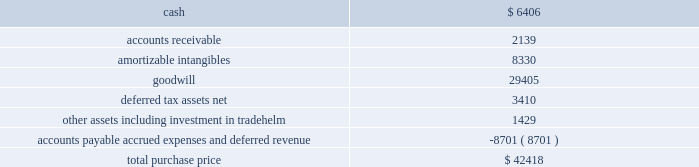Table of contents marketaxess holdings inc .
Notes to consolidated financial statements 2014 ( continued ) of this standard had no material effect on the company 2019s consolidated statements of financial condition and consolidated statements of operations .
Reclassifications certain reclassifications have been made to the prior years 2019 financial statements in order to conform to the current year presentation .
Such reclassifications had no effect on previously reported net income .
On march 5 , 2008 , the company acquired all of the outstanding capital stock of greenline financial technologies , inc .
( 201cgreenline 201d ) , an illinois-based provider of integration , testing and management solutions for fix-related products and services designed to optimize electronic trading of fixed-income , equity and other exchange-based products , and approximately ten percent of the outstanding capital stock of tradehelm , inc. , a delaware corporation that was spun-out from greenline immediately prior to the acquisition .
The acquisition of greenline broadens the range of technology services that the company offers to institutional financial markets , provides an expansion of the company 2019s client base , including global exchanges and hedge funds , and further diversifies the company 2019s revenues beyond the core electronic credit trading products .
The results of operations of greenline are included in the consolidated financial statements from the date of the acquisition .
The aggregate consideration for the greenline acquisition was $ 41.1 million , comprised of $ 34.7 million in cash , 725923 shares of common stock valued at $ 5.8 million and $ 0.6 million of acquisition-related costs .
In addition , the sellers were eligible to receive up to an aggregate of $ 3.0 million in cash , subject to greenline attaining certain earn- out targets in 2008 and 2009 .
A total of $ 1.4 million was paid to the sellers in 2009 based on the 2008 earn-out target , bringing the aggregate consideration to $ 42.4 million .
The 2009 earn-out target was not met .
A total of $ 2.0 million of the purchase price , which had been deposited into escrow accounts to satisfy potential indemnity claims , was distributed to the sellers in march 2009 .
The shares of common stock issued to each selling shareholder of greenline were released in two equal installments on december 20 , 2008 and december 20 , 2009 , respectively .
The value ascribed to the shares was discounted from the market value to reflect the non-marketability of such shares during the restriction period .
The purchase price allocation is as follows ( in thousands ) : the amortizable intangibles include $ 3.2 million of acquired technology , $ 3.3 million of customer relationships , $ 1.3 million of non-competition agreements and $ 0.5 million of tradenames .
Useful lives of ten years and five years have been assigned to the customer relationships intangible and all other amortizable intangibles , respectively .
The identifiable intangible assets and goodwill are not deductible for tax purposes .
The following unaudited pro forma consolidated financial information reflects the results of operations of the company for the years ended december 31 , 2008 and 2007 , as if the acquisition of greenline had occurred as of the beginning of the period presented , after giving effect to certain purchase accounting adjustments .
These pro forma results are not necessarily indicative of what the company 2019s operating results would have been had the acquisition actually taken place as of the beginning of the earliest period presented .
The pro forma financial information 3 .
Acquisitions .

What percentage of the purchase price makes up other assets including investment in tradehelm? 
Computations: (1429 / 42418)
Answer: 0.03369. Table of contents marketaxess holdings inc .
Notes to consolidated financial statements 2014 ( continued ) of this standard had no material effect on the company 2019s consolidated statements of financial condition and consolidated statements of operations .
Reclassifications certain reclassifications have been made to the prior years 2019 financial statements in order to conform to the current year presentation .
Such reclassifications had no effect on previously reported net income .
On march 5 , 2008 , the company acquired all of the outstanding capital stock of greenline financial technologies , inc .
( 201cgreenline 201d ) , an illinois-based provider of integration , testing and management solutions for fix-related products and services designed to optimize electronic trading of fixed-income , equity and other exchange-based products , and approximately ten percent of the outstanding capital stock of tradehelm , inc. , a delaware corporation that was spun-out from greenline immediately prior to the acquisition .
The acquisition of greenline broadens the range of technology services that the company offers to institutional financial markets , provides an expansion of the company 2019s client base , including global exchanges and hedge funds , and further diversifies the company 2019s revenues beyond the core electronic credit trading products .
The results of operations of greenline are included in the consolidated financial statements from the date of the acquisition .
The aggregate consideration for the greenline acquisition was $ 41.1 million , comprised of $ 34.7 million in cash , 725923 shares of common stock valued at $ 5.8 million and $ 0.6 million of acquisition-related costs .
In addition , the sellers were eligible to receive up to an aggregate of $ 3.0 million in cash , subject to greenline attaining certain earn- out targets in 2008 and 2009 .
A total of $ 1.4 million was paid to the sellers in 2009 based on the 2008 earn-out target , bringing the aggregate consideration to $ 42.4 million .
The 2009 earn-out target was not met .
A total of $ 2.0 million of the purchase price , which had been deposited into escrow accounts to satisfy potential indemnity claims , was distributed to the sellers in march 2009 .
The shares of common stock issued to each selling shareholder of greenline were released in two equal installments on december 20 , 2008 and december 20 , 2009 , respectively .
The value ascribed to the shares was discounted from the market value to reflect the non-marketability of such shares during the restriction period .
The purchase price allocation is as follows ( in thousands ) : the amortizable intangibles include $ 3.2 million of acquired technology , $ 3.3 million of customer relationships , $ 1.3 million of non-competition agreements and $ 0.5 million of tradenames .
Useful lives of ten years and five years have been assigned to the customer relationships intangible and all other amortizable intangibles , respectively .
The identifiable intangible assets and goodwill are not deductible for tax purposes .
The following unaudited pro forma consolidated financial information reflects the results of operations of the company for the years ended december 31 , 2008 and 2007 , as if the acquisition of greenline had occurred as of the beginning of the period presented , after giving effect to certain purchase accounting adjustments .
These pro forma results are not necessarily indicative of what the company 2019s operating results would have been had the acquisition actually taken place as of the beginning of the earliest period presented .
The pro forma financial information 3 .
Acquisitions .

What percentage of the purchase price makes up goodwill? 
Computations: (29405 / 42418)
Answer: 0.69322. 